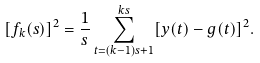<formula> <loc_0><loc_0><loc_500><loc_500>[ f _ { k } ( s ) ] ^ { 2 } = \frac { 1 } { s } \sum _ { t = ( k - 1 ) s + 1 } ^ { k s } [ y ( t ) - g ( t ) ] ^ { 2 } .</formula> 